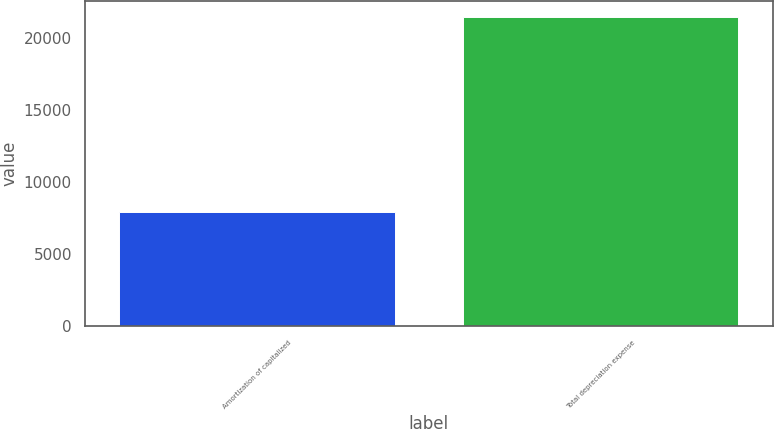Convert chart. <chart><loc_0><loc_0><loc_500><loc_500><bar_chart><fcel>Amortization of capitalized<fcel>Total depreciation expense<nl><fcel>7912<fcel>21504<nl></chart> 